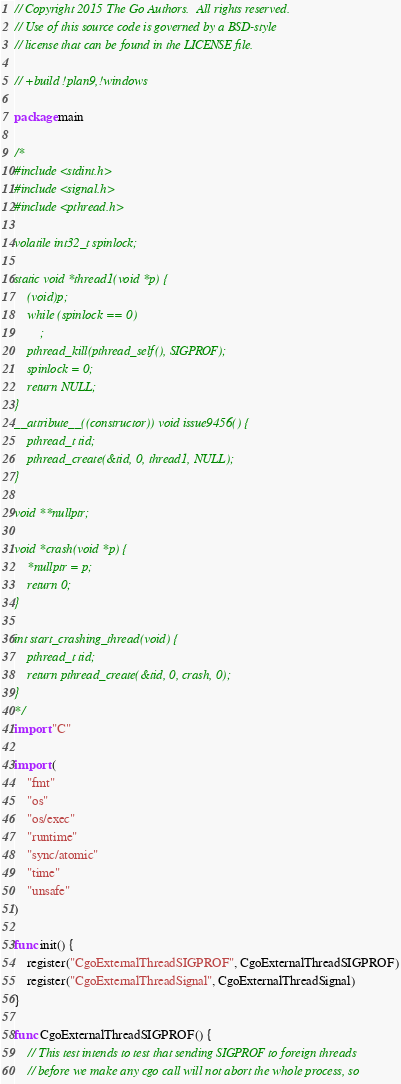<code> <loc_0><loc_0><loc_500><loc_500><_Go_>// Copyright 2015 The Go Authors.  All rights reserved.
// Use of this source code is governed by a BSD-style
// license that can be found in the LICENSE file.

// +build !plan9,!windows

package main

/*
#include <stdint.h>
#include <signal.h>
#include <pthread.h>

volatile int32_t spinlock;

static void *thread1(void *p) {
	(void)p;
	while (spinlock == 0)
		;
	pthread_kill(pthread_self(), SIGPROF);
	spinlock = 0;
	return NULL;
}
__attribute__((constructor)) void issue9456() {
	pthread_t tid;
	pthread_create(&tid, 0, thread1, NULL);
}

void **nullptr;

void *crash(void *p) {
	*nullptr = p;
	return 0;
}

int start_crashing_thread(void) {
	pthread_t tid;
	return pthread_create(&tid, 0, crash, 0);
}
*/
import "C"

import (
	"fmt"
	"os"
	"os/exec"
	"runtime"
	"sync/atomic"
	"time"
	"unsafe"
)

func init() {
	register("CgoExternalThreadSIGPROF", CgoExternalThreadSIGPROF)
	register("CgoExternalThreadSignal", CgoExternalThreadSignal)
}

func CgoExternalThreadSIGPROF() {
	// This test intends to test that sending SIGPROF to foreign threads
	// before we make any cgo call will not abort the whole process, so</code> 